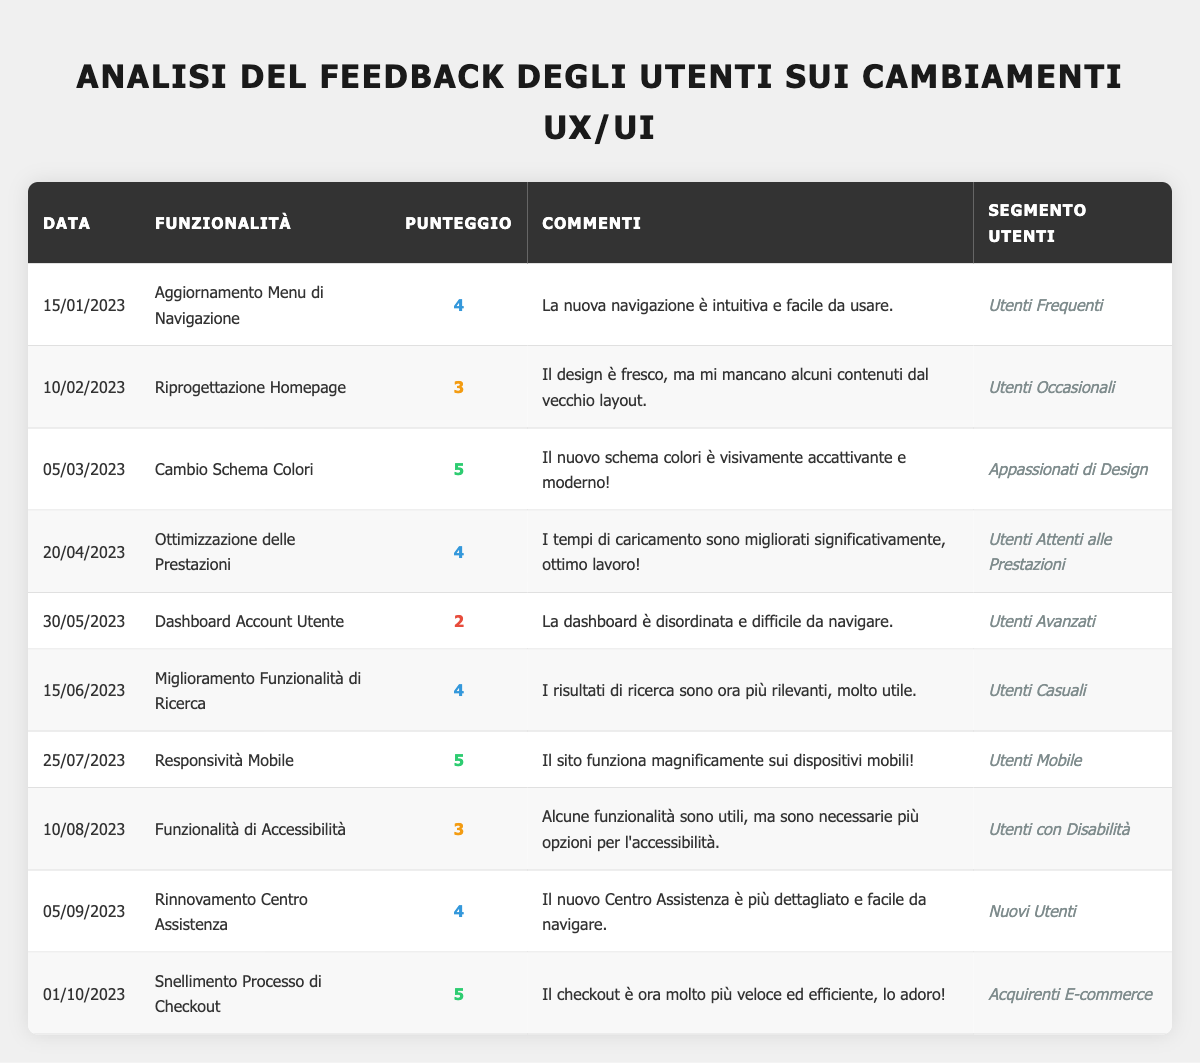What feature received the highest feedback score? The feedback scores are listed, and the highest score is 5. The features with this score are "Color Scheme Change" and "Checkout Process Streamlining."
Answer: "Color Scheme Change" and "Checkout Process Streamlining" What is the feedback score for the "User Account Dashboard" feature? The feedback score for the "User Account Dashboard" feature is listed as 2.
Answer: 2 How many features received a feedback score of 4? By reviewing the scores, the features with a score of 4 are: "Navigation Menu Update," "Performance Optimization," "Search Functionality Improvement," "Help Center Revamp." Thus, there are four features.
Answer: 4 Did "Mobile Responsiveness" receive a higher score than "Homepage Redesign"? "Mobile Responsiveness" has a score of 5, while "Homepage Redesign" has a score of 3. Since 5 is greater than 3, the statement is true.
Answer: Yes What is the average feedback score of all features? The scores are 4, 3, 5, 4, 2, 4, 5, 3, 4, 5. The sum of these scores is 4 + 3 + 5 + 4 + 2 + 4 + 5 + 3 + 4 + 5 = 43. There are 10 scores, so the average is 43 / 10 = 4.3.
Answer: 4.3 Which user segment provided feedback for the "Accessibility Features"? The user segment listed for "Accessibility Features" is "Users with Disabilities."
Answer: Users with Disabilities Was the feedback for "Checkout Process Streamlining" more positive than the feedback for "Dashboard Account Utente"? "Checkout Process Streamlining" has a score of 5, while "Dashboard Account Utente" has a score of 2. Since 5 is greater than 2, the feedback for "Checkout Process Streamlining" is more positive than that for "Dashboard Account Utente."
Answer: Yes What are the comments associated with "Search Functionality Improvement"? The comments for "Search Functionality Improvement" are "Search results are more relevant now, very helpful."
Answer: "Search results are more relevant now, very helpful." Identify the user segment with the lowest feedback score. The lowest feedback score is 2, associated with "User Account Dashboard," and the user segment is "Power Users."
Answer: Power Users 